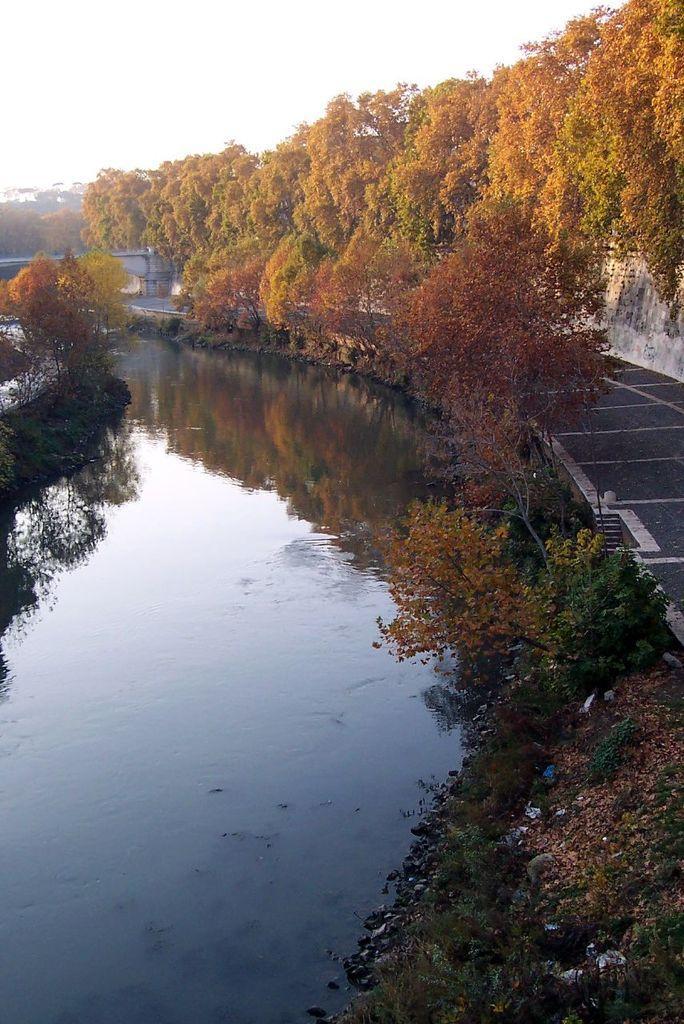Could you give a brief overview of what you see in this image? In this image there are trees on the right side. In the center there is water and the sky is cloudy. 